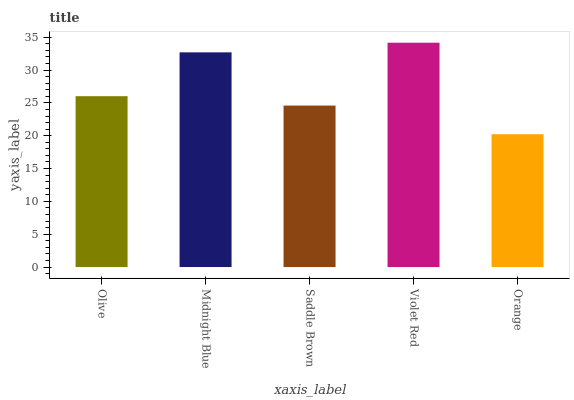Is Orange the minimum?
Answer yes or no. Yes. Is Violet Red the maximum?
Answer yes or no. Yes. Is Midnight Blue the minimum?
Answer yes or no. No. Is Midnight Blue the maximum?
Answer yes or no. No. Is Midnight Blue greater than Olive?
Answer yes or no. Yes. Is Olive less than Midnight Blue?
Answer yes or no. Yes. Is Olive greater than Midnight Blue?
Answer yes or no. No. Is Midnight Blue less than Olive?
Answer yes or no. No. Is Olive the high median?
Answer yes or no. Yes. Is Olive the low median?
Answer yes or no. Yes. Is Saddle Brown the high median?
Answer yes or no. No. Is Midnight Blue the low median?
Answer yes or no. No. 